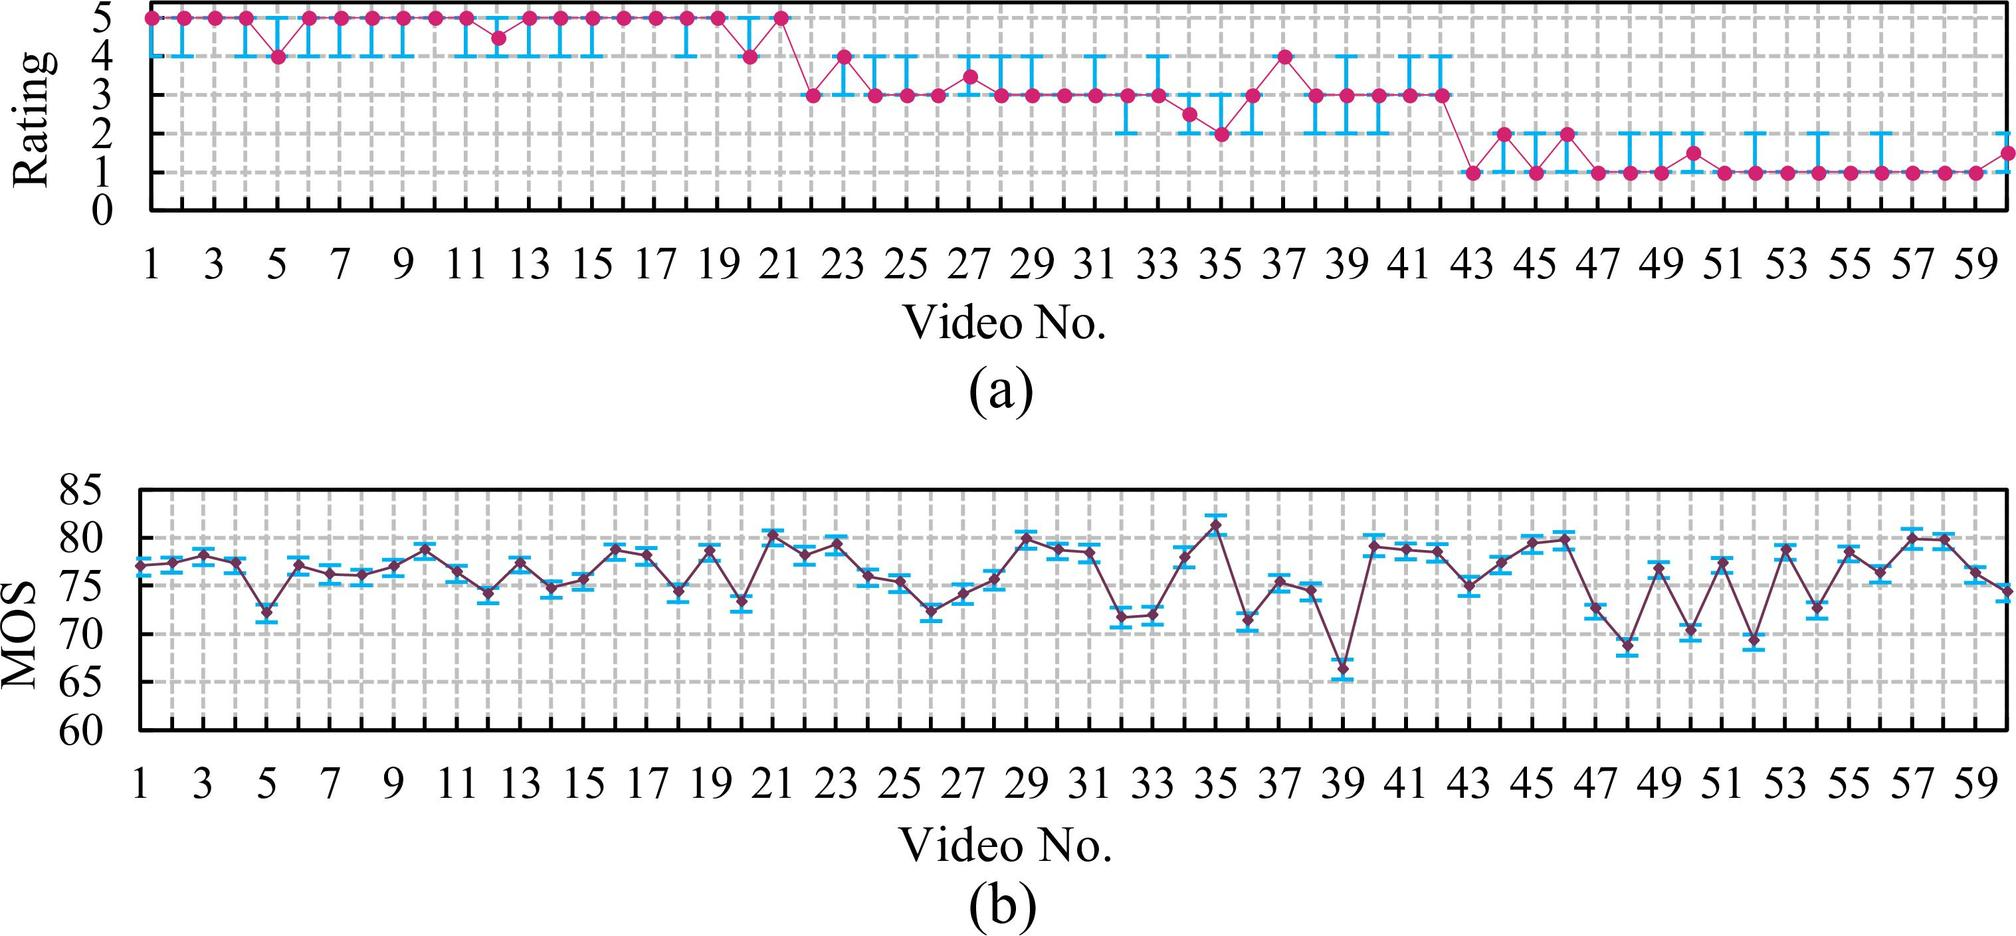What trend is observed in the ratings given to the videos in graph (a)? A. The ratings increase as the video number increases. B. The ratings remain constant throughout. C. The ratings decrease as the video number increases. D. The ratings fluctuate but overall remain around the same average. Graph (a) presents a nuanced picture of the ratings' trend across various videos. Though there's a discernible undulation in the ratings with occasional peaks and drops, the data doesn't display a consistent upward or downward trajectory. Instead, the ratings seem to hover around a central average value, though with a careful observation, one can notice a very subtle decline towards the end of the sequence. Despite this, the dominant characteristic of the pattern is the fluctuation within a general range, leading to the conclusion that option D is the most fitting answer. 